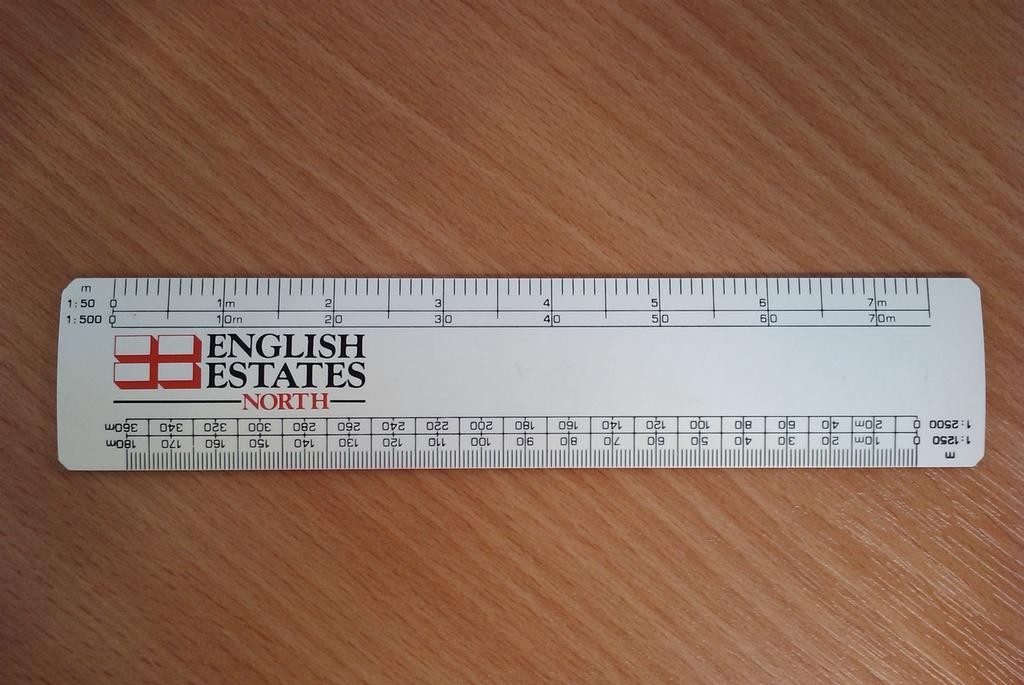<image>
Summarize the visual content of the image. A white ruler from English Estates North marked in inches and centimeters. 